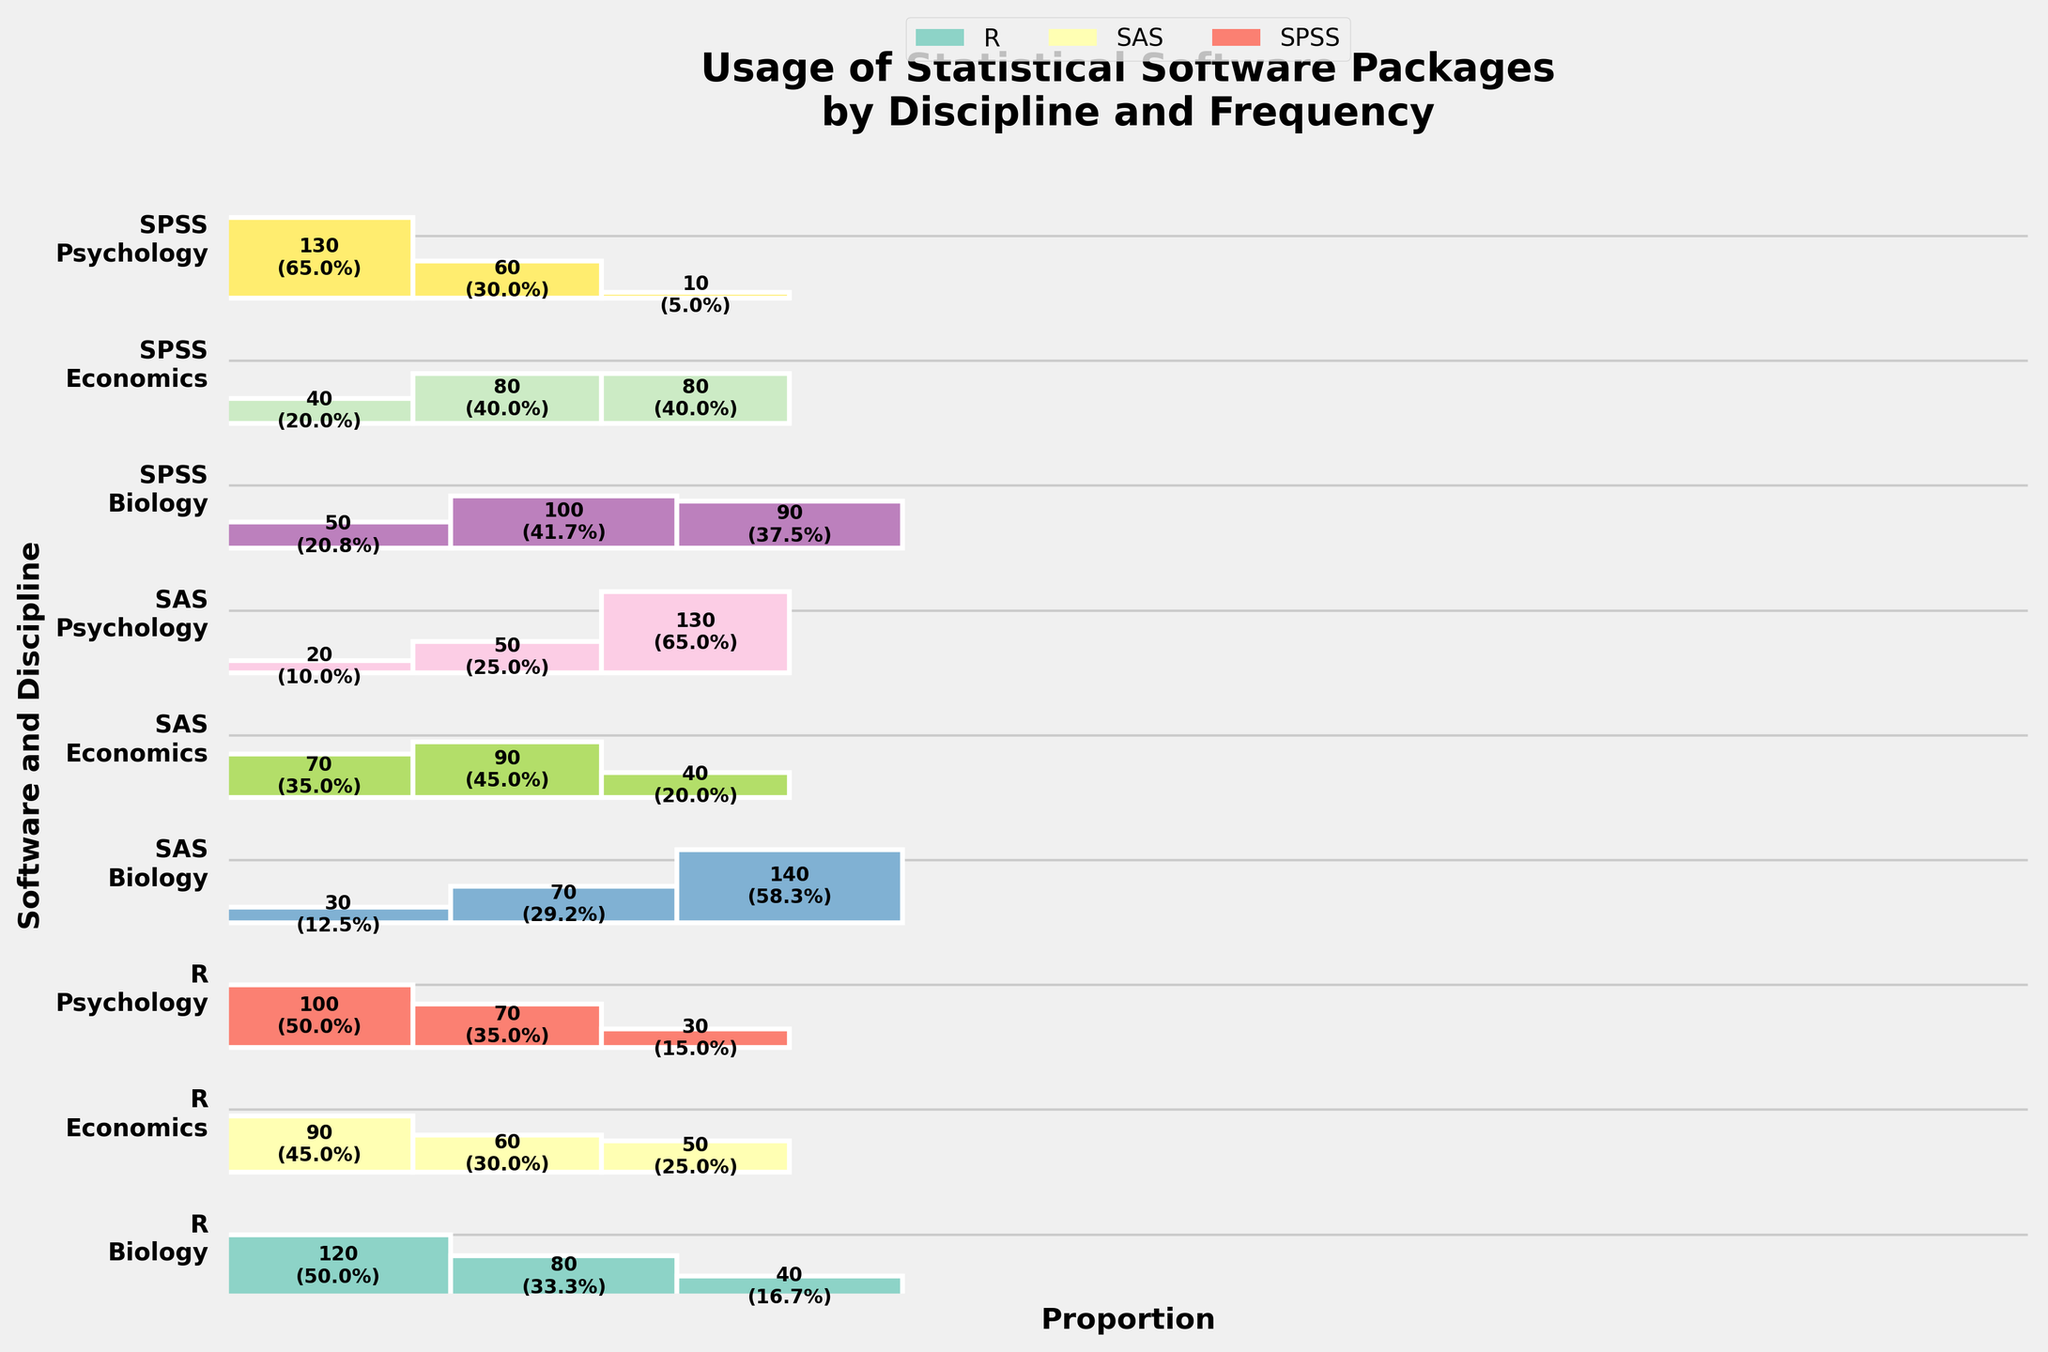what is the title of the plot? The title is shown prominently at the top of the plot. It describes the main subject of the visualization.
Answer: Usage of Statistical Software Packages by Discipline and Frequency Which software package is most frequently used in Biology? The frequency of usage is indicated on the y-axis for each software package within the Biology category. The software package with the highest proportion marked as "Frequent" is "R".
Answer: R Are there more frequent users of SPSS in Psychology or Economics? Compare the "Frequent" sections of SPSS between Psychology and Economics. The "Frequent" section of SPSS in Psychology is visibly larger than in Economics.
Answer: Psychology Which academic discipline has the highest rare usage of SAS? Look at the "Rare" sections for each academic discipline under SAS. The "Rare" section in Biology is the largest for SAS.
Answer: Biology What is the total number of occasional users of R across all academic disciplines? Sum the counts of "Occasional" users of R for Biology (80), Psychology (70), and Economics (60). Total is 80+70+60 = 210.
Answer: 210 Compare the frequent usage of R and SAS in Economics. Which one is higher and by how much? Look at the "Frequent" sections for R and SAS in Economics. For R, it’s 90, and for SAS, it’s 70. The difference is 90-70 = 20.
Answer: R, by 20 How is the frequency of usage of SPSS different in Biology versus Psychology? Analyze the three segments (Frequent, Occasional, Rare) of SPSS in both Biology and Psychology. SPSS in Biology has more occasional and rare users, while in Psychology, there are more frequent users.
Answer: Biology: More occasional and rare; Psychology: More frequent Which software has the largest number of rare users in Psychology? Look at the "Rare" sections for each software package in Psychology. SAS has the largest rare segment in Psychology.
Answer: SAS Are there more frequent users of SAS in Biology or rare users of SPSS in Economics? Compare the "Frequent" section of SAS in Biology with the "Rare" section of SPSS in Economics. The "Frequent" section of SAS in Biology is 30, and the "Rare" section of SPSS in Economics is 80.
Answer: Rare users of SPSS in Economics 